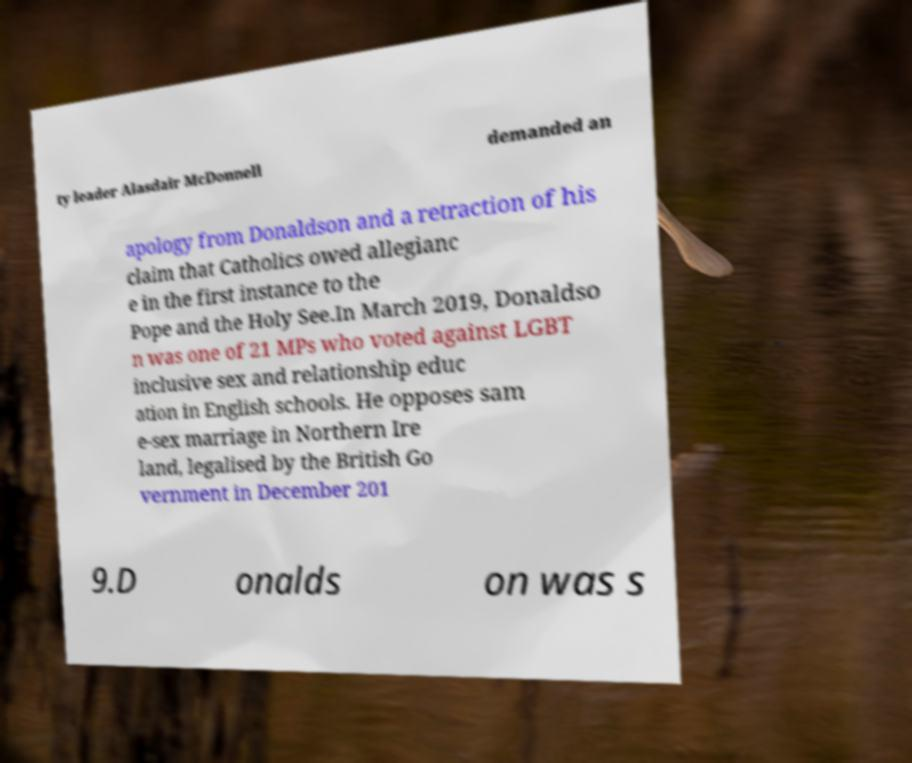I need the written content from this picture converted into text. Can you do that? ty leader Alasdair McDonnell demanded an apology from Donaldson and a retraction of his claim that Catholics owed allegianc e in the first instance to the Pope and the Holy See.In March 2019, Donaldso n was one of 21 MPs who voted against LGBT inclusive sex and relationship educ ation in English schools. He opposes sam e-sex marriage in Northern Ire land, legalised by the British Go vernment in December 201 9.D onalds on was s 